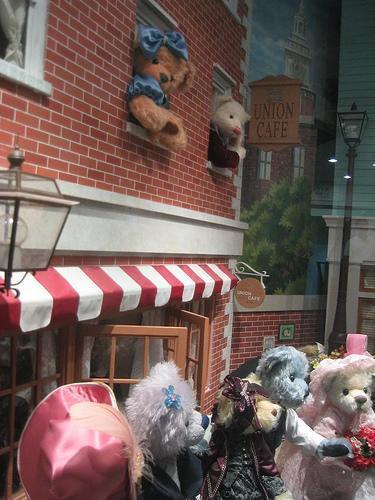How many street lamps are there?
Give a very brief answer. 2. 